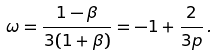<formula> <loc_0><loc_0><loc_500><loc_500>\omega = \frac { 1 - \beta } { 3 ( 1 + \beta ) } = - 1 + \frac { 2 } { 3 p } \, .</formula> 